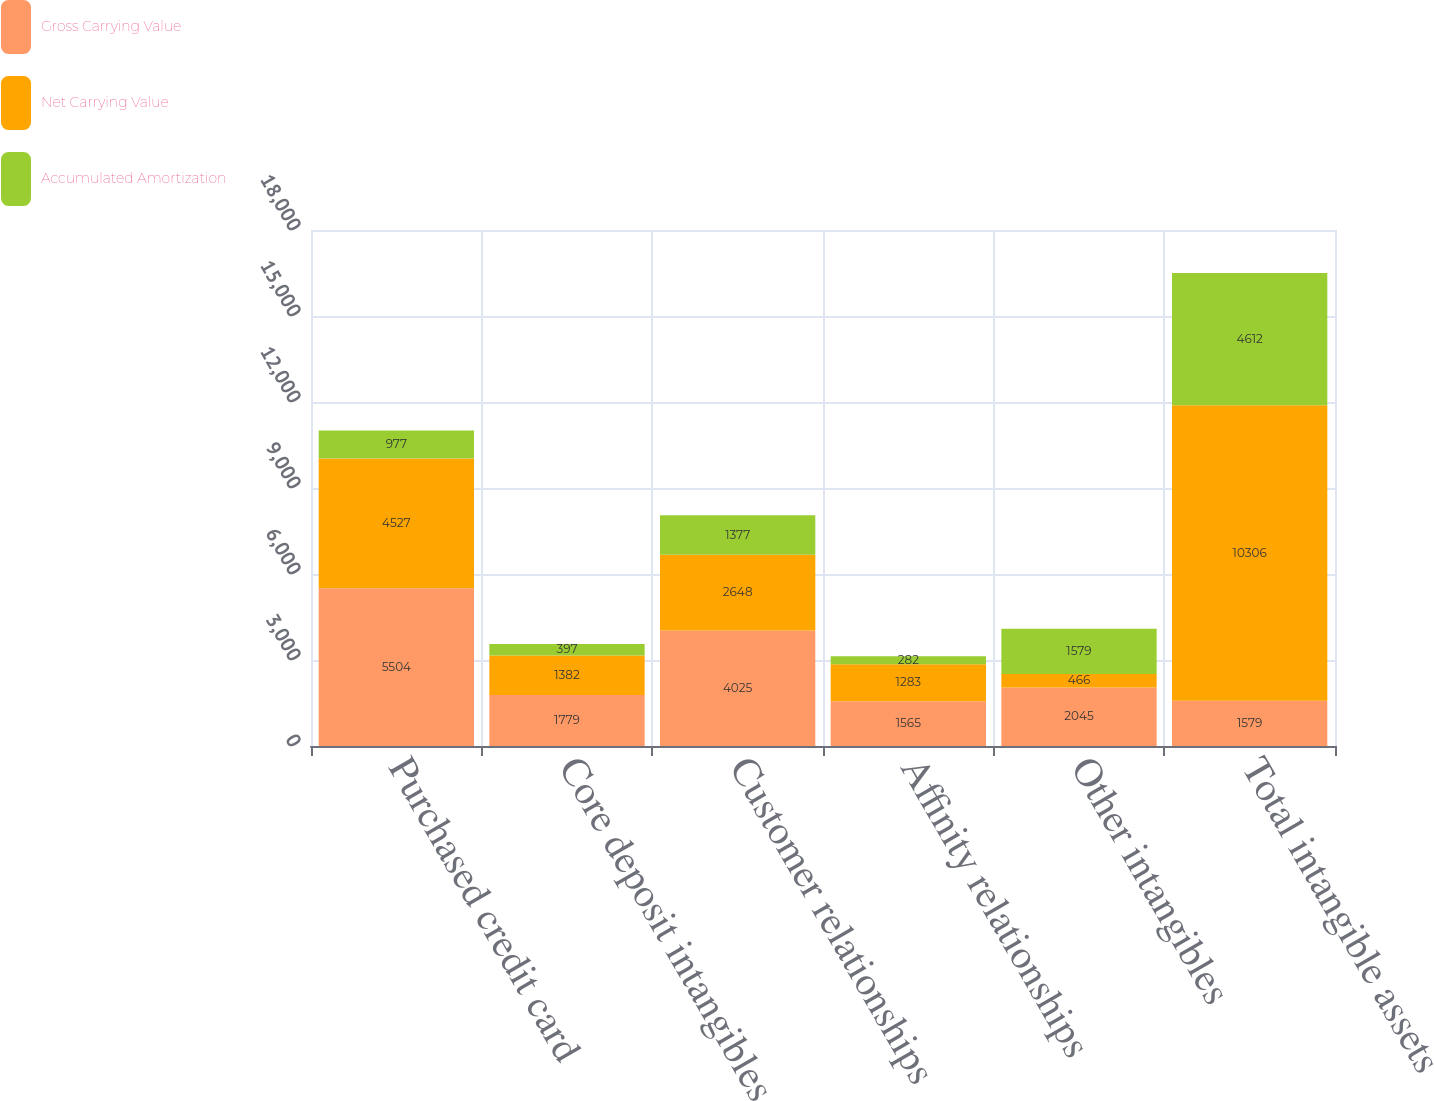Convert chart. <chart><loc_0><loc_0><loc_500><loc_500><stacked_bar_chart><ecel><fcel>Purchased credit card<fcel>Core deposit intangibles<fcel>Customer relationships<fcel>Affinity relationships<fcel>Other intangibles<fcel>Total intangible assets<nl><fcel>Gross Carrying Value<fcel>5504<fcel>1779<fcel>4025<fcel>1565<fcel>2045<fcel>1579<nl><fcel>Net Carrying Value<fcel>4527<fcel>1382<fcel>2648<fcel>1283<fcel>466<fcel>10306<nl><fcel>Accumulated Amortization<fcel>977<fcel>397<fcel>1377<fcel>282<fcel>1579<fcel>4612<nl></chart> 